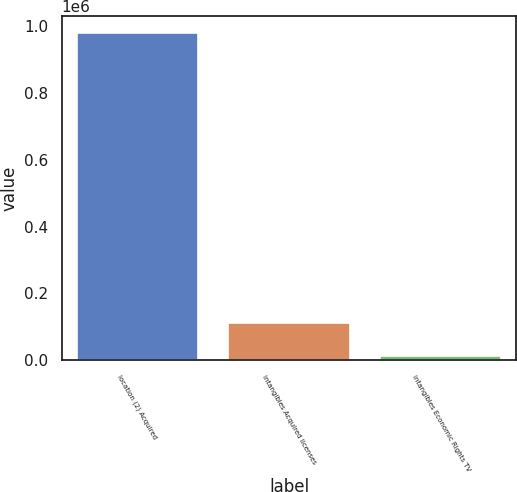Convert chart. <chart><loc_0><loc_0><loc_500><loc_500><bar_chart><fcel>location (2) Acquired<fcel>intangibles Acquired licenses<fcel>intangibles Economic Rights TV<nl><fcel>979264<fcel>110438<fcel>13902<nl></chart> 